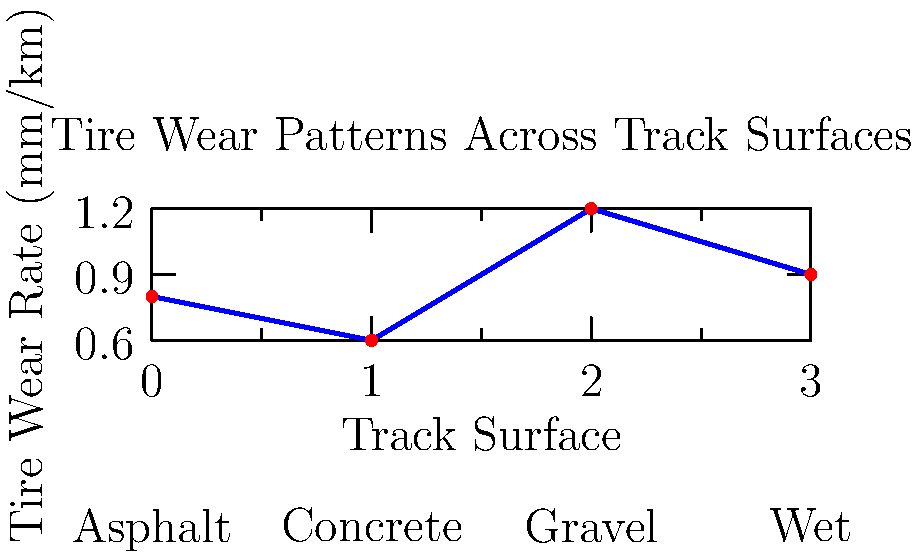Based on the graph showing tire wear patterns across different track surfaces, which surface type causes the highest rate of tire wear, and how much higher is this wear rate compared to the surface with the lowest wear rate? To answer this question, we need to follow these steps:

1. Identify the surface with the highest wear rate:
   Looking at the graph, we can see that the highest point corresponds to "Gravel" with a wear rate of approximately 1.2 mm/km.

2. Identify the surface with the lowest wear rate:
   The lowest point on the graph corresponds to "Concrete" with a wear rate of approximately 0.6 mm/km.

3. Calculate the difference in wear rates:
   Highest wear rate (Gravel): 1.2 mm/km
   Lowest wear rate (Concrete): 0.6 mm/km
   Difference: 1.2 - 0.6 = 0.6 mm/km

4. Calculate how much higher the wear rate is:
   To express this as a percentage or factor, we divide the higher rate by the lower rate:
   1.2 / 0.6 = 2

Therefore, the gravel surface causes the highest rate of tire wear, and this wear rate is 2 times (or 100% higher than) the wear rate on concrete, which has the lowest wear rate.
Answer: Gravel; 2 times higher 